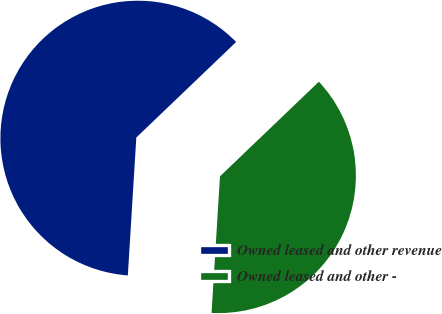Convert chart to OTSL. <chart><loc_0><loc_0><loc_500><loc_500><pie_chart><fcel>Owned leased and other revenue<fcel>Owned leased and other -<nl><fcel>61.87%<fcel>38.13%<nl></chart> 